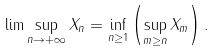<formula> <loc_0><loc_0><loc_500><loc_500>\lim \sup _ { n \rightarrow + \infty } X _ { n } = \inf _ { n \geq 1 } \left ( \sup _ { m \geq n } X _ { m } \right ) .</formula> 